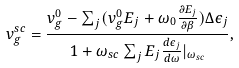Convert formula to latex. <formula><loc_0><loc_0><loc_500><loc_500>v _ { g } ^ { s c } = \frac { v _ { g } ^ { 0 } - \sum _ { j } ( v _ { g } ^ { 0 } E _ { j } + \omega _ { 0 } \frac { \partial E _ { j } } { \partial \beta } ) \Delta \epsilon _ { j } } { 1 + \omega _ { s c } \sum _ { j } E _ { j } \frac { d \epsilon _ { j } } { d \omega } | _ { \omega _ { s c } } } ,</formula> 